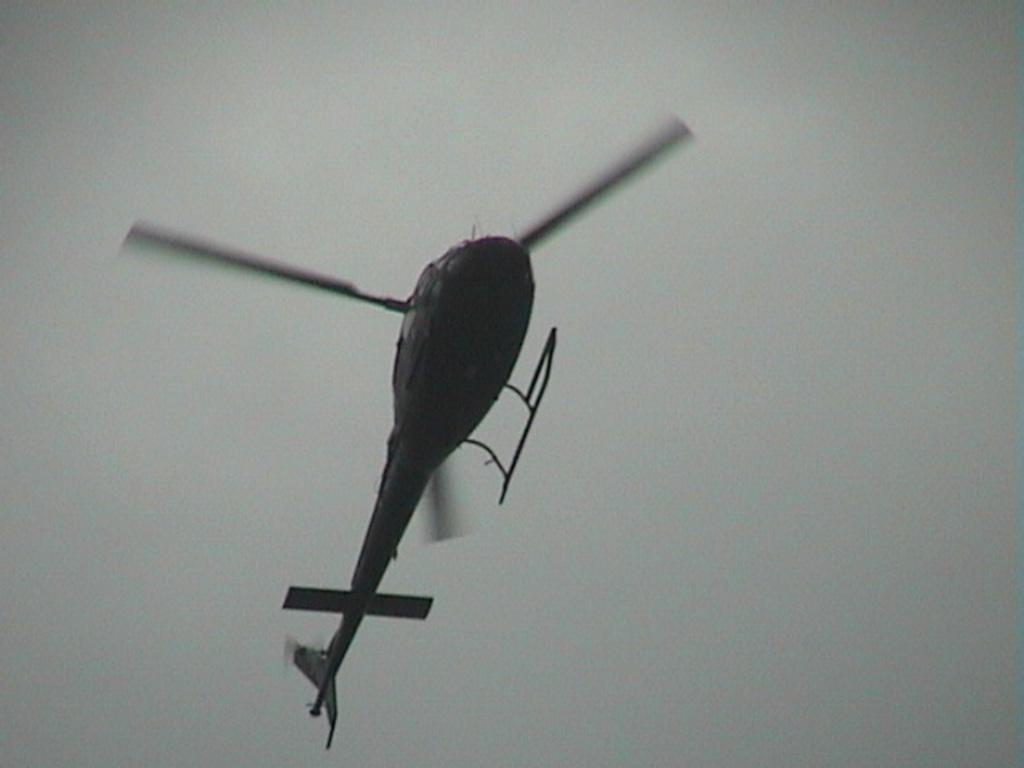What is flying in the sky in the image? A helicopter is flying in the sky. Can you describe the helicopter's position or movement in the image? The helicopter is flying in the sky, but the specific position or movement cannot be determined from the provided facts. What type of parcel is being smashed by the helicopter in the image? There is no parcel or smashing activity present in the image; it features a helicopter flying in the sky. How much waste is visible in the image? There is no waste visible in the image; it features a helicopter flying in the sky. 